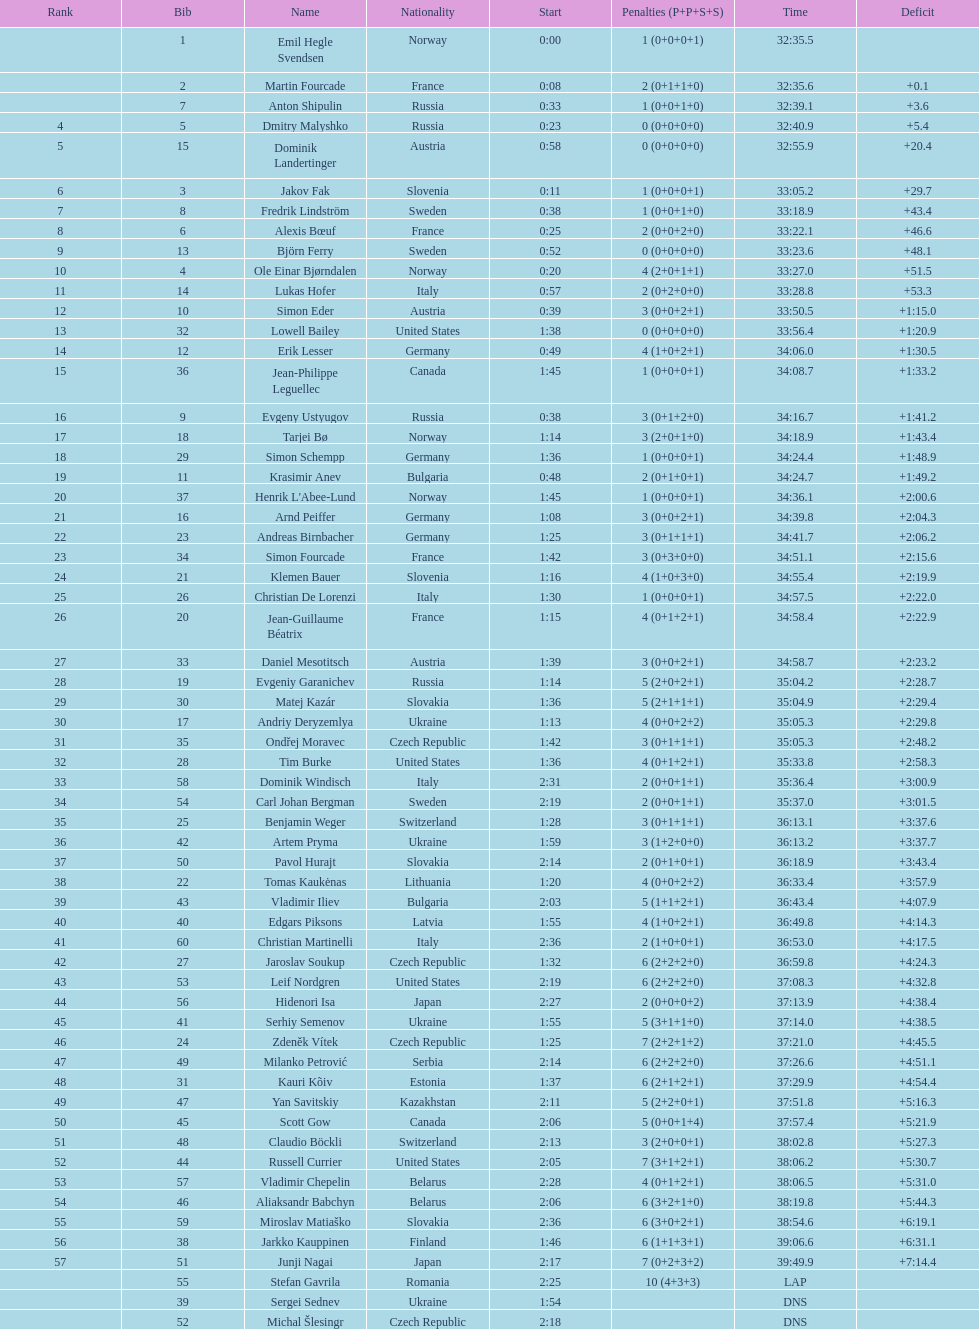How many individuals finished with a time of 35:00 or more? 30. 